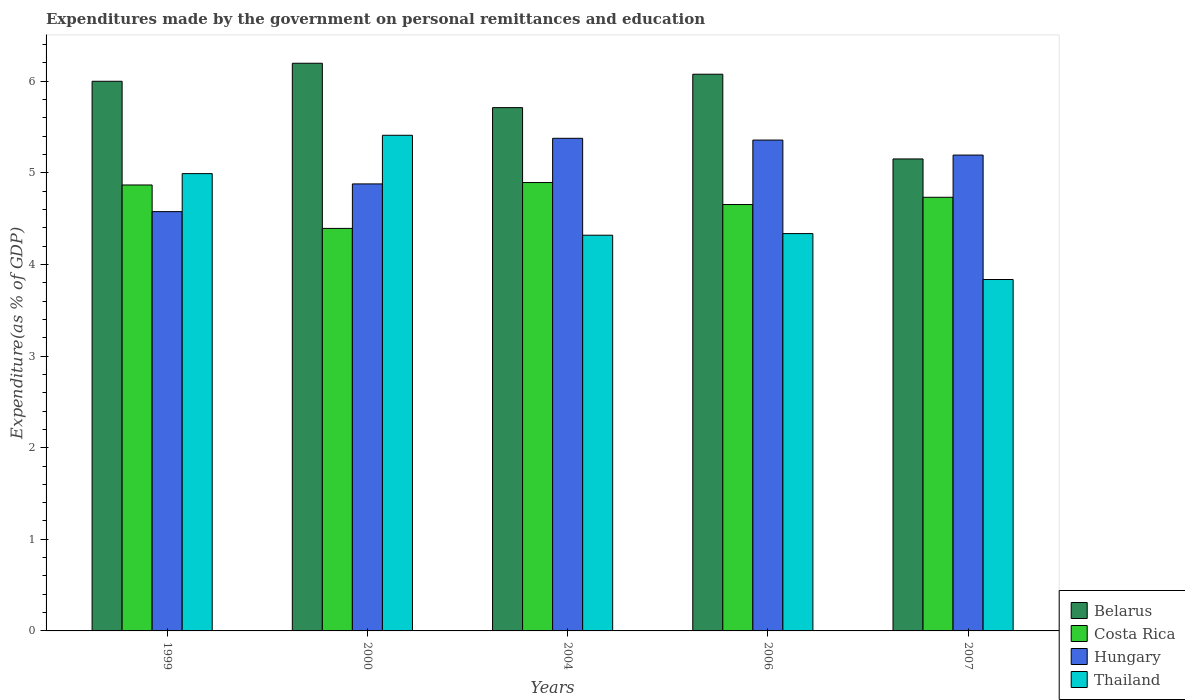Are the number of bars on each tick of the X-axis equal?
Your answer should be very brief. Yes. How many bars are there on the 5th tick from the left?
Your answer should be very brief. 4. What is the label of the 1st group of bars from the left?
Ensure brevity in your answer.  1999. What is the expenditures made by the government on personal remittances and education in Belarus in 2000?
Your answer should be compact. 6.2. Across all years, what is the maximum expenditures made by the government on personal remittances and education in Thailand?
Provide a short and direct response. 5.41. Across all years, what is the minimum expenditures made by the government on personal remittances and education in Belarus?
Give a very brief answer. 5.15. In which year was the expenditures made by the government on personal remittances and education in Costa Rica minimum?
Your answer should be compact. 2000. What is the total expenditures made by the government on personal remittances and education in Thailand in the graph?
Provide a succinct answer. 22.9. What is the difference between the expenditures made by the government on personal remittances and education in Belarus in 1999 and that in 2007?
Your answer should be compact. 0.85. What is the difference between the expenditures made by the government on personal remittances and education in Thailand in 2000 and the expenditures made by the government on personal remittances and education in Belarus in 1999?
Your answer should be compact. -0.59. What is the average expenditures made by the government on personal remittances and education in Thailand per year?
Make the answer very short. 4.58. In the year 1999, what is the difference between the expenditures made by the government on personal remittances and education in Hungary and expenditures made by the government on personal remittances and education in Thailand?
Your answer should be compact. -0.41. What is the ratio of the expenditures made by the government on personal remittances and education in Costa Rica in 1999 to that in 2007?
Make the answer very short. 1.03. Is the expenditures made by the government on personal remittances and education in Belarus in 2004 less than that in 2006?
Provide a short and direct response. Yes. Is the difference between the expenditures made by the government on personal remittances and education in Hungary in 1999 and 2006 greater than the difference between the expenditures made by the government on personal remittances and education in Thailand in 1999 and 2006?
Keep it short and to the point. No. What is the difference between the highest and the second highest expenditures made by the government on personal remittances and education in Thailand?
Your answer should be compact. 0.42. What is the difference between the highest and the lowest expenditures made by the government on personal remittances and education in Hungary?
Make the answer very short. 0.8. Is it the case that in every year, the sum of the expenditures made by the government on personal remittances and education in Thailand and expenditures made by the government on personal remittances and education in Hungary is greater than the sum of expenditures made by the government on personal remittances and education in Costa Rica and expenditures made by the government on personal remittances and education in Belarus?
Keep it short and to the point. No. What does the 3rd bar from the left in 2000 represents?
Offer a terse response. Hungary. What does the 1st bar from the right in 2007 represents?
Make the answer very short. Thailand. Are all the bars in the graph horizontal?
Offer a very short reply. No. What is the difference between two consecutive major ticks on the Y-axis?
Provide a short and direct response. 1. Does the graph contain any zero values?
Ensure brevity in your answer.  No. Does the graph contain grids?
Your answer should be compact. No. Where does the legend appear in the graph?
Provide a short and direct response. Bottom right. What is the title of the graph?
Your response must be concise. Expenditures made by the government on personal remittances and education. Does "Jamaica" appear as one of the legend labels in the graph?
Keep it short and to the point. No. What is the label or title of the Y-axis?
Provide a short and direct response. Expenditure(as % of GDP). What is the Expenditure(as % of GDP) of Belarus in 1999?
Your answer should be very brief. 6. What is the Expenditure(as % of GDP) in Costa Rica in 1999?
Your answer should be very brief. 4.87. What is the Expenditure(as % of GDP) in Hungary in 1999?
Make the answer very short. 4.58. What is the Expenditure(as % of GDP) in Thailand in 1999?
Make the answer very short. 4.99. What is the Expenditure(as % of GDP) of Belarus in 2000?
Give a very brief answer. 6.2. What is the Expenditure(as % of GDP) in Costa Rica in 2000?
Provide a short and direct response. 4.39. What is the Expenditure(as % of GDP) in Hungary in 2000?
Offer a very short reply. 4.88. What is the Expenditure(as % of GDP) in Thailand in 2000?
Provide a succinct answer. 5.41. What is the Expenditure(as % of GDP) of Belarus in 2004?
Ensure brevity in your answer.  5.71. What is the Expenditure(as % of GDP) of Costa Rica in 2004?
Keep it short and to the point. 4.89. What is the Expenditure(as % of GDP) of Hungary in 2004?
Provide a succinct answer. 5.38. What is the Expenditure(as % of GDP) in Thailand in 2004?
Offer a very short reply. 4.32. What is the Expenditure(as % of GDP) of Belarus in 2006?
Provide a short and direct response. 6.08. What is the Expenditure(as % of GDP) of Costa Rica in 2006?
Your answer should be very brief. 4.65. What is the Expenditure(as % of GDP) of Hungary in 2006?
Your answer should be compact. 5.36. What is the Expenditure(as % of GDP) of Thailand in 2006?
Your response must be concise. 4.34. What is the Expenditure(as % of GDP) of Belarus in 2007?
Your response must be concise. 5.15. What is the Expenditure(as % of GDP) in Costa Rica in 2007?
Your response must be concise. 4.73. What is the Expenditure(as % of GDP) of Hungary in 2007?
Provide a short and direct response. 5.19. What is the Expenditure(as % of GDP) of Thailand in 2007?
Make the answer very short. 3.84. Across all years, what is the maximum Expenditure(as % of GDP) in Belarus?
Offer a very short reply. 6.2. Across all years, what is the maximum Expenditure(as % of GDP) of Costa Rica?
Ensure brevity in your answer.  4.89. Across all years, what is the maximum Expenditure(as % of GDP) of Hungary?
Keep it short and to the point. 5.38. Across all years, what is the maximum Expenditure(as % of GDP) in Thailand?
Provide a succinct answer. 5.41. Across all years, what is the minimum Expenditure(as % of GDP) of Belarus?
Make the answer very short. 5.15. Across all years, what is the minimum Expenditure(as % of GDP) in Costa Rica?
Your response must be concise. 4.39. Across all years, what is the minimum Expenditure(as % of GDP) of Hungary?
Your answer should be very brief. 4.58. Across all years, what is the minimum Expenditure(as % of GDP) in Thailand?
Your answer should be very brief. 3.84. What is the total Expenditure(as % of GDP) of Belarus in the graph?
Your answer should be compact. 29.14. What is the total Expenditure(as % of GDP) in Costa Rica in the graph?
Your answer should be very brief. 23.54. What is the total Expenditure(as % of GDP) in Hungary in the graph?
Offer a very short reply. 25.39. What is the total Expenditure(as % of GDP) of Thailand in the graph?
Offer a terse response. 22.9. What is the difference between the Expenditure(as % of GDP) in Belarus in 1999 and that in 2000?
Provide a succinct answer. -0.2. What is the difference between the Expenditure(as % of GDP) of Costa Rica in 1999 and that in 2000?
Provide a succinct answer. 0.47. What is the difference between the Expenditure(as % of GDP) in Hungary in 1999 and that in 2000?
Your response must be concise. -0.3. What is the difference between the Expenditure(as % of GDP) in Thailand in 1999 and that in 2000?
Your response must be concise. -0.42. What is the difference between the Expenditure(as % of GDP) in Belarus in 1999 and that in 2004?
Provide a short and direct response. 0.29. What is the difference between the Expenditure(as % of GDP) of Costa Rica in 1999 and that in 2004?
Your answer should be compact. -0.03. What is the difference between the Expenditure(as % of GDP) in Hungary in 1999 and that in 2004?
Ensure brevity in your answer.  -0.8. What is the difference between the Expenditure(as % of GDP) in Thailand in 1999 and that in 2004?
Make the answer very short. 0.67. What is the difference between the Expenditure(as % of GDP) of Belarus in 1999 and that in 2006?
Your answer should be compact. -0.08. What is the difference between the Expenditure(as % of GDP) of Costa Rica in 1999 and that in 2006?
Make the answer very short. 0.21. What is the difference between the Expenditure(as % of GDP) of Hungary in 1999 and that in 2006?
Give a very brief answer. -0.78. What is the difference between the Expenditure(as % of GDP) in Thailand in 1999 and that in 2006?
Provide a succinct answer. 0.65. What is the difference between the Expenditure(as % of GDP) in Belarus in 1999 and that in 2007?
Give a very brief answer. 0.85. What is the difference between the Expenditure(as % of GDP) of Costa Rica in 1999 and that in 2007?
Offer a terse response. 0.13. What is the difference between the Expenditure(as % of GDP) in Hungary in 1999 and that in 2007?
Ensure brevity in your answer.  -0.62. What is the difference between the Expenditure(as % of GDP) of Thailand in 1999 and that in 2007?
Provide a succinct answer. 1.16. What is the difference between the Expenditure(as % of GDP) in Belarus in 2000 and that in 2004?
Provide a succinct answer. 0.48. What is the difference between the Expenditure(as % of GDP) of Costa Rica in 2000 and that in 2004?
Give a very brief answer. -0.5. What is the difference between the Expenditure(as % of GDP) in Hungary in 2000 and that in 2004?
Your response must be concise. -0.5. What is the difference between the Expenditure(as % of GDP) of Thailand in 2000 and that in 2004?
Offer a very short reply. 1.09. What is the difference between the Expenditure(as % of GDP) of Belarus in 2000 and that in 2006?
Your answer should be very brief. 0.12. What is the difference between the Expenditure(as % of GDP) of Costa Rica in 2000 and that in 2006?
Provide a succinct answer. -0.26. What is the difference between the Expenditure(as % of GDP) of Hungary in 2000 and that in 2006?
Provide a short and direct response. -0.48. What is the difference between the Expenditure(as % of GDP) in Thailand in 2000 and that in 2006?
Make the answer very short. 1.07. What is the difference between the Expenditure(as % of GDP) in Belarus in 2000 and that in 2007?
Your response must be concise. 1.04. What is the difference between the Expenditure(as % of GDP) in Costa Rica in 2000 and that in 2007?
Keep it short and to the point. -0.34. What is the difference between the Expenditure(as % of GDP) in Hungary in 2000 and that in 2007?
Provide a succinct answer. -0.31. What is the difference between the Expenditure(as % of GDP) of Thailand in 2000 and that in 2007?
Offer a very short reply. 1.57. What is the difference between the Expenditure(as % of GDP) of Belarus in 2004 and that in 2006?
Your answer should be very brief. -0.36. What is the difference between the Expenditure(as % of GDP) of Costa Rica in 2004 and that in 2006?
Give a very brief answer. 0.24. What is the difference between the Expenditure(as % of GDP) in Hungary in 2004 and that in 2006?
Your answer should be compact. 0.02. What is the difference between the Expenditure(as % of GDP) of Thailand in 2004 and that in 2006?
Provide a succinct answer. -0.02. What is the difference between the Expenditure(as % of GDP) in Belarus in 2004 and that in 2007?
Your answer should be very brief. 0.56. What is the difference between the Expenditure(as % of GDP) of Costa Rica in 2004 and that in 2007?
Offer a very short reply. 0.16. What is the difference between the Expenditure(as % of GDP) in Hungary in 2004 and that in 2007?
Your answer should be very brief. 0.18. What is the difference between the Expenditure(as % of GDP) of Thailand in 2004 and that in 2007?
Your answer should be very brief. 0.48. What is the difference between the Expenditure(as % of GDP) of Belarus in 2006 and that in 2007?
Your answer should be very brief. 0.92. What is the difference between the Expenditure(as % of GDP) of Costa Rica in 2006 and that in 2007?
Provide a short and direct response. -0.08. What is the difference between the Expenditure(as % of GDP) of Hungary in 2006 and that in 2007?
Keep it short and to the point. 0.16. What is the difference between the Expenditure(as % of GDP) of Thailand in 2006 and that in 2007?
Offer a very short reply. 0.5. What is the difference between the Expenditure(as % of GDP) in Belarus in 1999 and the Expenditure(as % of GDP) in Costa Rica in 2000?
Give a very brief answer. 1.61. What is the difference between the Expenditure(as % of GDP) in Belarus in 1999 and the Expenditure(as % of GDP) in Hungary in 2000?
Your answer should be compact. 1.12. What is the difference between the Expenditure(as % of GDP) of Belarus in 1999 and the Expenditure(as % of GDP) of Thailand in 2000?
Ensure brevity in your answer.  0.59. What is the difference between the Expenditure(as % of GDP) of Costa Rica in 1999 and the Expenditure(as % of GDP) of Hungary in 2000?
Your response must be concise. -0.01. What is the difference between the Expenditure(as % of GDP) of Costa Rica in 1999 and the Expenditure(as % of GDP) of Thailand in 2000?
Your answer should be very brief. -0.54. What is the difference between the Expenditure(as % of GDP) of Hungary in 1999 and the Expenditure(as % of GDP) of Thailand in 2000?
Give a very brief answer. -0.83. What is the difference between the Expenditure(as % of GDP) of Belarus in 1999 and the Expenditure(as % of GDP) of Costa Rica in 2004?
Make the answer very short. 1.11. What is the difference between the Expenditure(as % of GDP) in Belarus in 1999 and the Expenditure(as % of GDP) in Hungary in 2004?
Keep it short and to the point. 0.62. What is the difference between the Expenditure(as % of GDP) of Belarus in 1999 and the Expenditure(as % of GDP) of Thailand in 2004?
Make the answer very short. 1.68. What is the difference between the Expenditure(as % of GDP) of Costa Rica in 1999 and the Expenditure(as % of GDP) of Hungary in 2004?
Provide a succinct answer. -0.51. What is the difference between the Expenditure(as % of GDP) in Costa Rica in 1999 and the Expenditure(as % of GDP) in Thailand in 2004?
Keep it short and to the point. 0.55. What is the difference between the Expenditure(as % of GDP) of Hungary in 1999 and the Expenditure(as % of GDP) of Thailand in 2004?
Your response must be concise. 0.26. What is the difference between the Expenditure(as % of GDP) in Belarus in 1999 and the Expenditure(as % of GDP) in Costa Rica in 2006?
Ensure brevity in your answer.  1.35. What is the difference between the Expenditure(as % of GDP) in Belarus in 1999 and the Expenditure(as % of GDP) in Hungary in 2006?
Provide a short and direct response. 0.64. What is the difference between the Expenditure(as % of GDP) in Belarus in 1999 and the Expenditure(as % of GDP) in Thailand in 2006?
Offer a very short reply. 1.66. What is the difference between the Expenditure(as % of GDP) in Costa Rica in 1999 and the Expenditure(as % of GDP) in Hungary in 2006?
Your response must be concise. -0.49. What is the difference between the Expenditure(as % of GDP) of Costa Rica in 1999 and the Expenditure(as % of GDP) of Thailand in 2006?
Your response must be concise. 0.53. What is the difference between the Expenditure(as % of GDP) of Hungary in 1999 and the Expenditure(as % of GDP) of Thailand in 2006?
Your answer should be very brief. 0.24. What is the difference between the Expenditure(as % of GDP) of Belarus in 1999 and the Expenditure(as % of GDP) of Costa Rica in 2007?
Make the answer very short. 1.27. What is the difference between the Expenditure(as % of GDP) of Belarus in 1999 and the Expenditure(as % of GDP) of Hungary in 2007?
Make the answer very short. 0.81. What is the difference between the Expenditure(as % of GDP) in Belarus in 1999 and the Expenditure(as % of GDP) in Thailand in 2007?
Make the answer very short. 2.16. What is the difference between the Expenditure(as % of GDP) of Costa Rica in 1999 and the Expenditure(as % of GDP) of Hungary in 2007?
Provide a succinct answer. -0.33. What is the difference between the Expenditure(as % of GDP) in Costa Rica in 1999 and the Expenditure(as % of GDP) in Thailand in 2007?
Offer a very short reply. 1.03. What is the difference between the Expenditure(as % of GDP) of Hungary in 1999 and the Expenditure(as % of GDP) of Thailand in 2007?
Make the answer very short. 0.74. What is the difference between the Expenditure(as % of GDP) in Belarus in 2000 and the Expenditure(as % of GDP) in Costa Rica in 2004?
Provide a succinct answer. 1.3. What is the difference between the Expenditure(as % of GDP) in Belarus in 2000 and the Expenditure(as % of GDP) in Hungary in 2004?
Keep it short and to the point. 0.82. What is the difference between the Expenditure(as % of GDP) of Belarus in 2000 and the Expenditure(as % of GDP) of Thailand in 2004?
Your answer should be very brief. 1.88. What is the difference between the Expenditure(as % of GDP) of Costa Rica in 2000 and the Expenditure(as % of GDP) of Hungary in 2004?
Ensure brevity in your answer.  -0.98. What is the difference between the Expenditure(as % of GDP) in Costa Rica in 2000 and the Expenditure(as % of GDP) in Thailand in 2004?
Make the answer very short. 0.07. What is the difference between the Expenditure(as % of GDP) of Hungary in 2000 and the Expenditure(as % of GDP) of Thailand in 2004?
Make the answer very short. 0.56. What is the difference between the Expenditure(as % of GDP) in Belarus in 2000 and the Expenditure(as % of GDP) in Costa Rica in 2006?
Offer a terse response. 1.54. What is the difference between the Expenditure(as % of GDP) in Belarus in 2000 and the Expenditure(as % of GDP) in Hungary in 2006?
Provide a succinct answer. 0.84. What is the difference between the Expenditure(as % of GDP) in Belarus in 2000 and the Expenditure(as % of GDP) in Thailand in 2006?
Offer a very short reply. 1.86. What is the difference between the Expenditure(as % of GDP) in Costa Rica in 2000 and the Expenditure(as % of GDP) in Hungary in 2006?
Ensure brevity in your answer.  -0.96. What is the difference between the Expenditure(as % of GDP) in Costa Rica in 2000 and the Expenditure(as % of GDP) in Thailand in 2006?
Your answer should be compact. 0.06. What is the difference between the Expenditure(as % of GDP) in Hungary in 2000 and the Expenditure(as % of GDP) in Thailand in 2006?
Give a very brief answer. 0.54. What is the difference between the Expenditure(as % of GDP) of Belarus in 2000 and the Expenditure(as % of GDP) of Costa Rica in 2007?
Keep it short and to the point. 1.46. What is the difference between the Expenditure(as % of GDP) in Belarus in 2000 and the Expenditure(as % of GDP) in Hungary in 2007?
Offer a terse response. 1. What is the difference between the Expenditure(as % of GDP) of Belarus in 2000 and the Expenditure(as % of GDP) of Thailand in 2007?
Provide a succinct answer. 2.36. What is the difference between the Expenditure(as % of GDP) in Costa Rica in 2000 and the Expenditure(as % of GDP) in Hungary in 2007?
Your answer should be compact. -0.8. What is the difference between the Expenditure(as % of GDP) of Costa Rica in 2000 and the Expenditure(as % of GDP) of Thailand in 2007?
Give a very brief answer. 0.56. What is the difference between the Expenditure(as % of GDP) in Hungary in 2000 and the Expenditure(as % of GDP) in Thailand in 2007?
Ensure brevity in your answer.  1.04. What is the difference between the Expenditure(as % of GDP) of Belarus in 2004 and the Expenditure(as % of GDP) of Costa Rica in 2006?
Your response must be concise. 1.06. What is the difference between the Expenditure(as % of GDP) in Belarus in 2004 and the Expenditure(as % of GDP) in Hungary in 2006?
Your answer should be compact. 0.35. What is the difference between the Expenditure(as % of GDP) in Belarus in 2004 and the Expenditure(as % of GDP) in Thailand in 2006?
Your answer should be very brief. 1.38. What is the difference between the Expenditure(as % of GDP) in Costa Rica in 2004 and the Expenditure(as % of GDP) in Hungary in 2006?
Your response must be concise. -0.46. What is the difference between the Expenditure(as % of GDP) of Costa Rica in 2004 and the Expenditure(as % of GDP) of Thailand in 2006?
Make the answer very short. 0.56. What is the difference between the Expenditure(as % of GDP) in Hungary in 2004 and the Expenditure(as % of GDP) in Thailand in 2006?
Your answer should be compact. 1.04. What is the difference between the Expenditure(as % of GDP) in Belarus in 2004 and the Expenditure(as % of GDP) in Costa Rica in 2007?
Your answer should be very brief. 0.98. What is the difference between the Expenditure(as % of GDP) of Belarus in 2004 and the Expenditure(as % of GDP) of Hungary in 2007?
Your answer should be very brief. 0.52. What is the difference between the Expenditure(as % of GDP) of Belarus in 2004 and the Expenditure(as % of GDP) of Thailand in 2007?
Offer a very short reply. 1.88. What is the difference between the Expenditure(as % of GDP) in Costa Rica in 2004 and the Expenditure(as % of GDP) in Hungary in 2007?
Ensure brevity in your answer.  -0.3. What is the difference between the Expenditure(as % of GDP) of Costa Rica in 2004 and the Expenditure(as % of GDP) of Thailand in 2007?
Give a very brief answer. 1.06. What is the difference between the Expenditure(as % of GDP) of Hungary in 2004 and the Expenditure(as % of GDP) of Thailand in 2007?
Offer a terse response. 1.54. What is the difference between the Expenditure(as % of GDP) in Belarus in 2006 and the Expenditure(as % of GDP) in Costa Rica in 2007?
Your answer should be compact. 1.34. What is the difference between the Expenditure(as % of GDP) in Belarus in 2006 and the Expenditure(as % of GDP) in Hungary in 2007?
Your answer should be very brief. 0.88. What is the difference between the Expenditure(as % of GDP) in Belarus in 2006 and the Expenditure(as % of GDP) in Thailand in 2007?
Offer a very short reply. 2.24. What is the difference between the Expenditure(as % of GDP) of Costa Rica in 2006 and the Expenditure(as % of GDP) of Hungary in 2007?
Provide a short and direct response. -0.54. What is the difference between the Expenditure(as % of GDP) in Costa Rica in 2006 and the Expenditure(as % of GDP) in Thailand in 2007?
Your answer should be compact. 0.82. What is the difference between the Expenditure(as % of GDP) in Hungary in 2006 and the Expenditure(as % of GDP) in Thailand in 2007?
Your answer should be very brief. 1.52. What is the average Expenditure(as % of GDP) of Belarus per year?
Make the answer very short. 5.83. What is the average Expenditure(as % of GDP) of Costa Rica per year?
Offer a terse response. 4.71. What is the average Expenditure(as % of GDP) in Hungary per year?
Your answer should be compact. 5.08. What is the average Expenditure(as % of GDP) in Thailand per year?
Make the answer very short. 4.58. In the year 1999, what is the difference between the Expenditure(as % of GDP) in Belarus and Expenditure(as % of GDP) in Costa Rica?
Your response must be concise. 1.13. In the year 1999, what is the difference between the Expenditure(as % of GDP) of Belarus and Expenditure(as % of GDP) of Hungary?
Offer a terse response. 1.42. In the year 1999, what is the difference between the Expenditure(as % of GDP) of Belarus and Expenditure(as % of GDP) of Thailand?
Keep it short and to the point. 1.01. In the year 1999, what is the difference between the Expenditure(as % of GDP) of Costa Rica and Expenditure(as % of GDP) of Hungary?
Offer a very short reply. 0.29. In the year 1999, what is the difference between the Expenditure(as % of GDP) of Costa Rica and Expenditure(as % of GDP) of Thailand?
Your answer should be very brief. -0.12. In the year 1999, what is the difference between the Expenditure(as % of GDP) in Hungary and Expenditure(as % of GDP) in Thailand?
Your response must be concise. -0.41. In the year 2000, what is the difference between the Expenditure(as % of GDP) of Belarus and Expenditure(as % of GDP) of Costa Rica?
Make the answer very short. 1.8. In the year 2000, what is the difference between the Expenditure(as % of GDP) in Belarus and Expenditure(as % of GDP) in Hungary?
Make the answer very short. 1.32. In the year 2000, what is the difference between the Expenditure(as % of GDP) of Belarus and Expenditure(as % of GDP) of Thailand?
Your answer should be very brief. 0.79. In the year 2000, what is the difference between the Expenditure(as % of GDP) in Costa Rica and Expenditure(as % of GDP) in Hungary?
Your answer should be very brief. -0.49. In the year 2000, what is the difference between the Expenditure(as % of GDP) of Costa Rica and Expenditure(as % of GDP) of Thailand?
Your answer should be compact. -1.02. In the year 2000, what is the difference between the Expenditure(as % of GDP) of Hungary and Expenditure(as % of GDP) of Thailand?
Provide a short and direct response. -0.53. In the year 2004, what is the difference between the Expenditure(as % of GDP) in Belarus and Expenditure(as % of GDP) in Costa Rica?
Your answer should be compact. 0.82. In the year 2004, what is the difference between the Expenditure(as % of GDP) of Belarus and Expenditure(as % of GDP) of Hungary?
Provide a short and direct response. 0.33. In the year 2004, what is the difference between the Expenditure(as % of GDP) in Belarus and Expenditure(as % of GDP) in Thailand?
Provide a short and direct response. 1.39. In the year 2004, what is the difference between the Expenditure(as % of GDP) in Costa Rica and Expenditure(as % of GDP) in Hungary?
Offer a terse response. -0.48. In the year 2004, what is the difference between the Expenditure(as % of GDP) in Costa Rica and Expenditure(as % of GDP) in Thailand?
Provide a short and direct response. 0.57. In the year 2004, what is the difference between the Expenditure(as % of GDP) in Hungary and Expenditure(as % of GDP) in Thailand?
Your answer should be very brief. 1.06. In the year 2006, what is the difference between the Expenditure(as % of GDP) in Belarus and Expenditure(as % of GDP) in Costa Rica?
Provide a short and direct response. 1.42. In the year 2006, what is the difference between the Expenditure(as % of GDP) in Belarus and Expenditure(as % of GDP) in Hungary?
Give a very brief answer. 0.72. In the year 2006, what is the difference between the Expenditure(as % of GDP) in Belarus and Expenditure(as % of GDP) in Thailand?
Offer a very short reply. 1.74. In the year 2006, what is the difference between the Expenditure(as % of GDP) in Costa Rica and Expenditure(as % of GDP) in Hungary?
Your answer should be very brief. -0.7. In the year 2006, what is the difference between the Expenditure(as % of GDP) in Costa Rica and Expenditure(as % of GDP) in Thailand?
Your answer should be very brief. 0.32. In the year 2006, what is the difference between the Expenditure(as % of GDP) of Hungary and Expenditure(as % of GDP) of Thailand?
Ensure brevity in your answer.  1.02. In the year 2007, what is the difference between the Expenditure(as % of GDP) in Belarus and Expenditure(as % of GDP) in Costa Rica?
Your answer should be very brief. 0.42. In the year 2007, what is the difference between the Expenditure(as % of GDP) in Belarus and Expenditure(as % of GDP) in Hungary?
Make the answer very short. -0.04. In the year 2007, what is the difference between the Expenditure(as % of GDP) in Belarus and Expenditure(as % of GDP) in Thailand?
Offer a very short reply. 1.32. In the year 2007, what is the difference between the Expenditure(as % of GDP) of Costa Rica and Expenditure(as % of GDP) of Hungary?
Make the answer very short. -0.46. In the year 2007, what is the difference between the Expenditure(as % of GDP) of Costa Rica and Expenditure(as % of GDP) of Thailand?
Your answer should be compact. 0.9. In the year 2007, what is the difference between the Expenditure(as % of GDP) in Hungary and Expenditure(as % of GDP) in Thailand?
Your response must be concise. 1.36. What is the ratio of the Expenditure(as % of GDP) of Belarus in 1999 to that in 2000?
Keep it short and to the point. 0.97. What is the ratio of the Expenditure(as % of GDP) in Costa Rica in 1999 to that in 2000?
Keep it short and to the point. 1.11. What is the ratio of the Expenditure(as % of GDP) of Hungary in 1999 to that in 2000?
Keep it short and to the point. 0.94. What is the ratio of the Expenditure(as % of GDP) of Thailand in 1999 to that in 2000?
Your response must be concise. 0.92. What is the ratio of the Expenditure(as % of GDP) in Belarus in 1999 to that in 2004?
Your answer should be compact. 1.05. What is the ratio of the Expenditure(as % of GDP) in Hungary in 1999 to that in 2004?
Offer a very short reply. 0.85. What is the ratio of the Expenditure(as % of GDP) of Thailand in 1999 to that in 2004?
Provide a short and direct response. 1.16. What is the ratio of the Expenditure(as % of GDP) in Belarus in 1999 to that in 2006?
Offer a terse response. 0.99. What is the ratio of the Expenditure(as % of GDP) in Costa Rica in 1999 to that in 2006?
Make the answer very short. 1.05. What is the ratio of the Expenditure(as % of GDP) of Hungary in 1999 to that in 2006?
Make the answer very short. 0.85. What is the ratio of the Expenditure(as % of GDP) of Thailand in 1999 to that in 2006?
Your response must be concise. 1.15. What is the ratio of the Expenditure(as % of GDP) of Belarus in 1999 to that in 2007?
Offer a very short reply. 1.16. What is the ratio of the Expenditure(as % of GDP) of Costa Rica in 1999 to that in 2007?
Your answer should be very brief. 1.03. What is the ratio of the Expenditure(as % of GDP) of Hungary in 1999 to that in 2007?
Keep it short and to the point. 0.88. What is the ratio of the Expenditure(as % of GDP) of Thailand in 1999 to that in 2007?
Offer a very short reply. 1.3. What is the ratio of the Expenditure(as % of GDP) in Belarus in 2000 to that in 2004?
Provide a succinct answer. 1.08. What is the ratio of the Expenditure(as % of GDP) in Costa Rica in 2000 to that in 2004?
Provide a succinct answer. 0.9. What is the ratio of the Expenditure(as % of GDP) in Hungary in 2000 to that in 2004?
Provide a succinct answer. 0.91. What is the ratio of the Expenditure(as % of GDP) of Thailand in 2000 to that in 2004?
Keep it short and to the point. 1.25. What is the ratio of the Expenditure(as % of GDP) in Belarus in 2000 to that in 2006?
Offer a terse response. 1.02. What is the ratio of the Expenditure(as % of GDP) of Costa Rica in 2000 to that in 2006?
Provide a succinct answer. 0.94. What is the ratio of the Expenditure(as % of GDP) of Hungary in 2000 to that in 2006?
Keep it short and to the point. 0.91. What is the ratio of the Expenditure(as % of GDP) in Thailand in 2000 to that in 2006?
Make the answer very short. 1.25. What is the ratio of the Expenditure(as % of GDP) of Belarus in 2000 to that in 2007?
Ensure brevity in your answer.  1.2. What is the ratio of the Expenditure(as % of GDP) of Costa Rica in 2000 to that in 2007?
Your answer should be very brief. 0.93. What is the ratio of the Expenditure(as % of GDP) of Hungary in 2000 to that in 2007?
Provide a short and direct response. 0.94. What is the ratio of the Expenditure(as % of GDP) of Thailand in 2000 to that in 2007?
Give a very brief answer. 1.41. What is the ratio of the Expenditure(as % of GDP) in Belarus in 2004 to that in 2006?
Keep it short and to the point. 0.94. What is the ratio of the Expenditure(as % of GDP) in Costa Rica in 2004 to that in 2006?
Provide a short and direct response. 1.05. What is the ratio of the Expenditure(as % of GDP) of Thailand in 2004 to that in 2006?
Your response must be concise. 1. What is the ratio of the Expenditure(as % of GDP) in Belarus in 2004 to that in 2007?
Your response must be concise. 1.11. What is the ratio of the Expenditure(as % of GDP) of Costa Rica in 2004 to that in 2007?
Your response must be concise. 1.03. What is the ratio of the Expenditure(as % of GDP) in Hungary in 2004 to that in 2007?
Make the answer very short. 1.04. What is the ratio of the Expenditure(as % of GDP) in Thailand in 2004 to that in 2007?
Your answer should be compact. 1.13. What is the ratio of the Expenditure(as % of GDP) in Belarus in 2006 to that in 2007?
Keep it short and to the point. 1.18. What is the ratio of the Expenditure(as % of GDP) in Costa Rica in 2006 to that in 2007?
Make the answer very short. 0.98. What is the ratio of the Expenditure(as % of GDP) in Hungary in 2006 to that in 2007?
Keep it short and to the point. 1.03. What is the ratio of the Expenditure(as % of GDP) in Thailand in 2006 to that in 2007?
Ensure brevity in your answer.  1.13. What is the difference between the highest and the second highest Expenditure(as % of GDP) in Belarus?
Offer a very short reply. 0.12. What is the difference between the highest and the second highest Expenditure(as % of GDP) of Costa Rica?
Your answer should be very brief. 0.03. What is the difference between the highest and the second highest Expenditure(as % of GDP) in Hungary?
Ensure brevity in your answer.  0.02. What is the difference between the highest and the second highest Expenditure(as % of GDP) of Thailand?
Your answer should be compact. 0.42. What is the difference between the highest and the lowest Expenditure(as % of GDP) in Belarus?
Ensure brevity in your answer.  1.04. What is the difference between the highest and the lowest Expenditure(as % of GDP) of Costa Rica?
Your answer should be very brief. 0.5. What is the difference between the highest and the lowest Expenditure(as % of GDP) in Hungary?
Offer a terse response. 0.8. What is the difference between the highest and the lowest Expenditure(as % of GDP) in Thailand?
Ensure brevity in your answer.  1.57. 